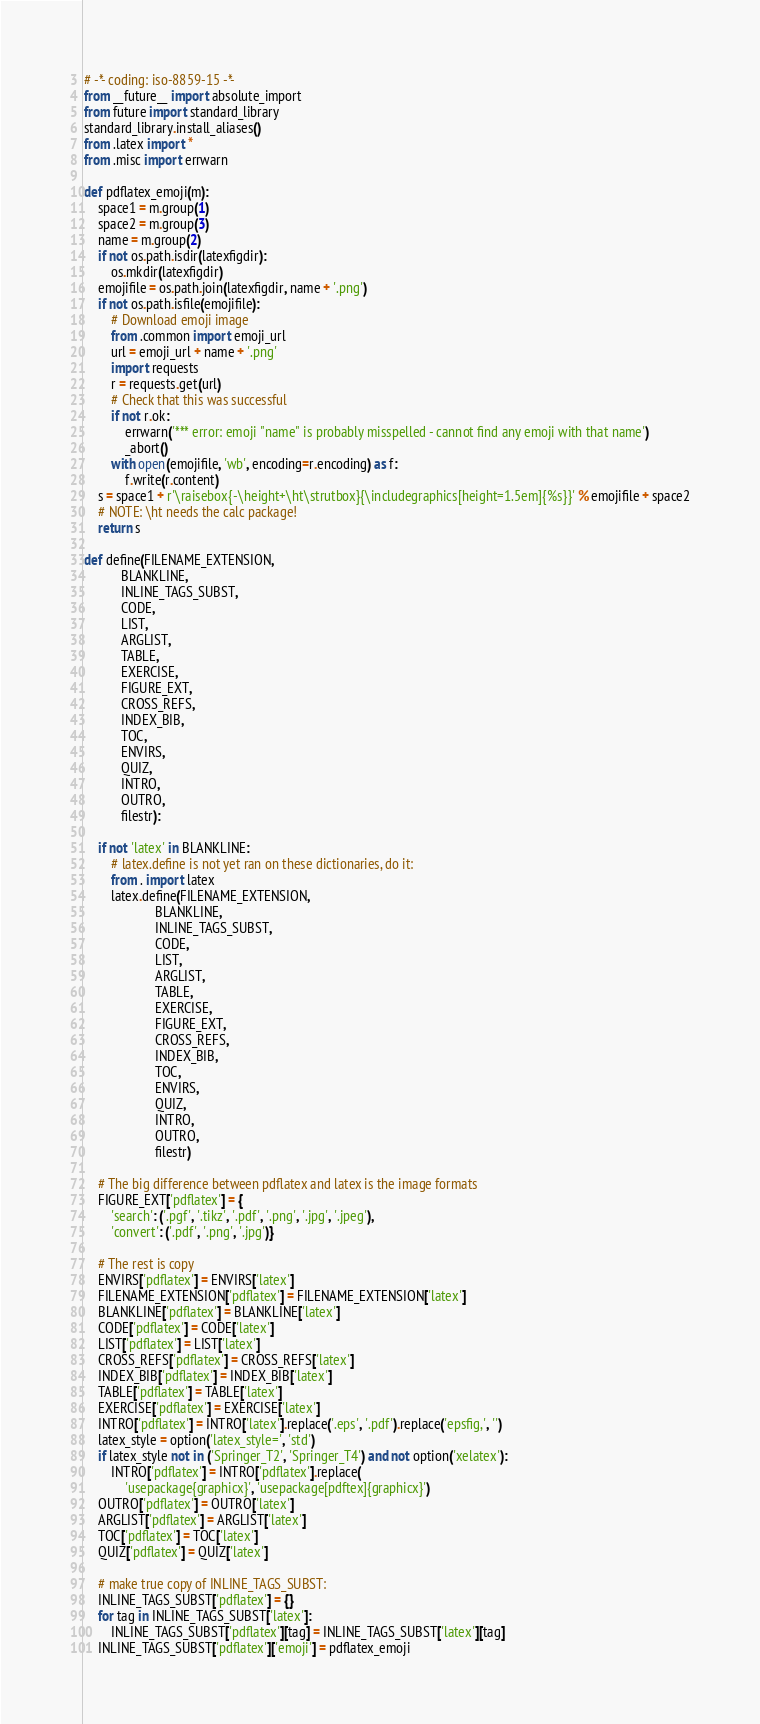Convert code to text. <code><loc_0><loc_0><loc_500><loc_500><_Python_># -*- coding: iso-8859-15 -*-
from __future__ import absolute_import
from future import standard_library
standard_library.install_aliases()
from .latex import *
from .misc import errwarn

def pdflatex_emoji(m):
    space1 = m.group(1)
    space2 = m.group(3)
    name = m.group(2)
    if not os.path.isdir(latexfigdir):
        os.mkdir(latexfigdir)
    emojifile = os.path.join(latexfigdir, name + '.png')
    if not os.path.isfile(emojifile):
        # Download emoji image
        from .common import emoji_url
        url = emoji_url + name + '.png'
        import requests
        r = requests.get(url)
        # Check that this was successful
        if not r.ok:
            errwarn('*** error: emoji "name" is probably misspelled - cannot find any emoji with that name')
            _abort()
        with open(emojifile, 'wb', encoding=r.encoding) as f:
            f.write(r.content)
    s = space1 + r'\raisebox{-\height+\ht\strutbox}{\includegraphics[height=1.5em]{%s}}' % emojifile + space2
    # NOTE: \ht needs the calc package!
    return s

def define(FILENAME_EXTENSION,
           BLANKLINE,
           INLINE_TAGS_SUBST,
           CODE,
           LIST,
           ARGLIST,
           TABLE,
           EXERCISE,
           FIGURE_EXT,
           CROSS_REFS,
           INDEX_BIB,
           TOC,
           ENVIRS,
           QUIZ,
           INTRO,
           OUTRO,
           filestr):

    if not 'latex' in BLANKLINE:
        # latex.define is not yet ran on these dictionaries, do it:
        from . import latex
        latex.define(FILENAME_EXTENSION,
                     BLANKLINE,
                     INLINE_TAGS_SUBST,
                     CODE,
                     LIST,
                     ARGLIST,
                     TABLE,
                     EXERCISE,
                     FIGURE_EXT,
                     CROSS_REFS,
                     INDEX_BIB,
                     TOC,
                     ENVIRS,
                     QUIZ,
                     INTRO,
                     OUTRO,
                     filestr)

    # The big difference between pdflatex and latex is the image formats
    FIGURE_EXT['pdflatex'] = {
        'search': ('.pgf', '.tikz', '.pdf', '.png', '.jpg', '.jpeg'),
        'convert': ('.pdf', '.png', '.jpg')}

    # The rest is copy
    ENVIRS['pdflatex'] = ENVIRS['latex']
    FILENAME_EXTENSION['pdflatex'] = FILENAME_EXTENSION['latex']
    BLANKLINE['pdflatex'] = BLANKLINE['latex']
    CODE['pdflatex'] = CODE['latex']
    LIST['pdflatex'] = LIST['latex']
    CROSS_REFS['pdflatex'] = CROSS_REFS['latex']
    INDEX_BIB['pdflatex'] = INDEX_BIB['latex']
    TABLE['pdflatex'] = TABLE['latex']
    EXERCISE['pdflatex'] = EXERCISE['latex']
    INTRO['pdflatex'] = INTRO['latex'].replace('.eps', '.pdf').replace('epsfig,', '')
    latex_style = option('latex_style=', 'std')
    if latex_style not in ('Springer_T2', 'Springer_T4') and not option('xelatex'):
        INTRO['pdflatex'] = INTRO['pdflatex'].replace(
            'usepackage{graphicx}', 'usepackage[pdftex]{graphicx}')
    OUTRO['pdflatex'] = OUTRO['latex']
    ARGLIST['pdflatex'] = ARGLIST['latex']
    TOC['pdflatex'] = TOC['latex']
    QUIZ['pdflatex'] = QUIZ['latex']

    # make true copy of INLINE_TAGS_SUBST:
    INLINE_TAGS_SUBST['pdflatex'] = {}
    for tag in INLINE_TAGS_SUBST['latex']:
        INLINE_TAGS_SUBST['pdflatex'][tag] = INLINE_TAGS_SUBST['latex'][tag]
    INLINE_TAGS_SUBST['pdflatex']['emoji'] = pdflatex_emoji
</code> 